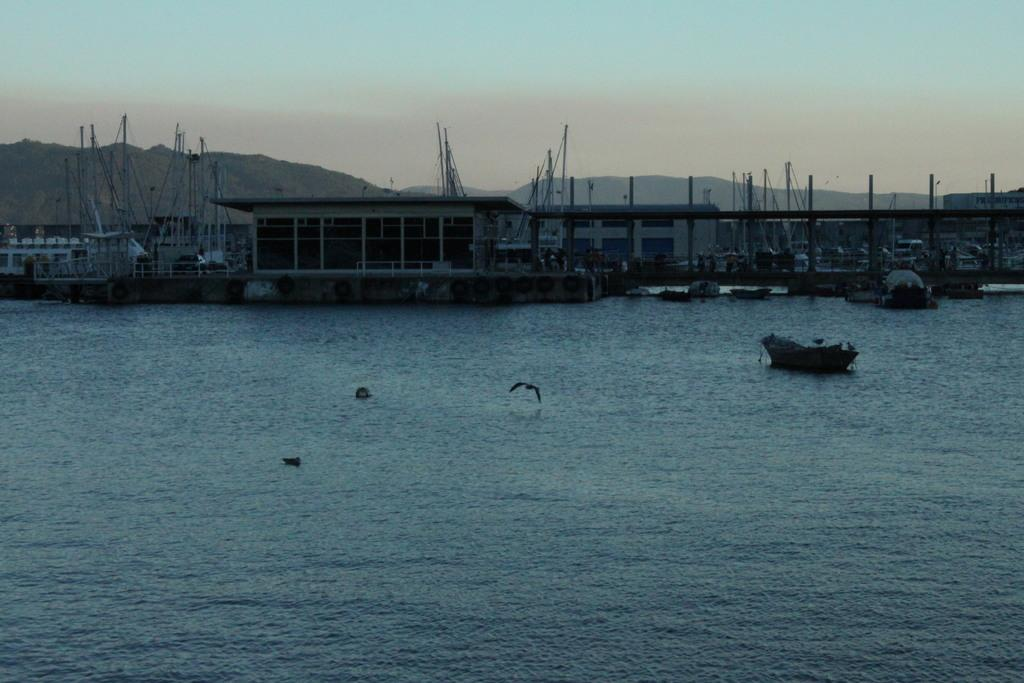What is located in front of the image? There is water in front of the image. What is the main subject in the center of the image? There is a bird in the center of the image. What type of structures can be seen in the background of the image? There are buildings and boards in the background of the image. What natural features are visible in the background of the image? There are mountains and the sky visible in the background of the image. What type of education can be seen on the quilt in the image? There is no quilt or education present in the image. What type of cracker is being used to create the mountains in the image? There are no crackers or artificial means used to create the mountains in the image; they are natural features. 